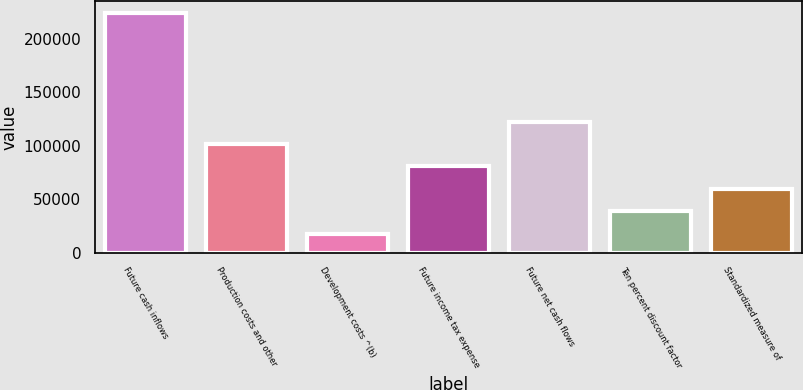<chart> <loc_0><loc_0><loc_500><loc_500><bar_chart><fcel>Future cash inflows<fcel>Production costs and other<fcel>Development costs ^(b)<fcel>Future income tax expense<fcel>Future net cash flows<fcel>Ten percent discount factor<fcel>Standardized measure of<nl><fcel>223665<fcel>101150<fcel>17756<fcel>80558.8<fcel>121741<fcel>39377<fcel>59967.9<nl></chart> 